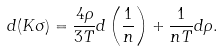<formula> <loc_0><loc_0><loc_500><loc_500>d ( K \sigma ) = \frac { 4 \rho } { 3 T } d \left ( \frac { 1 } { n } \right ) + \frac { 1 } { n T } d \rho .</formula> 